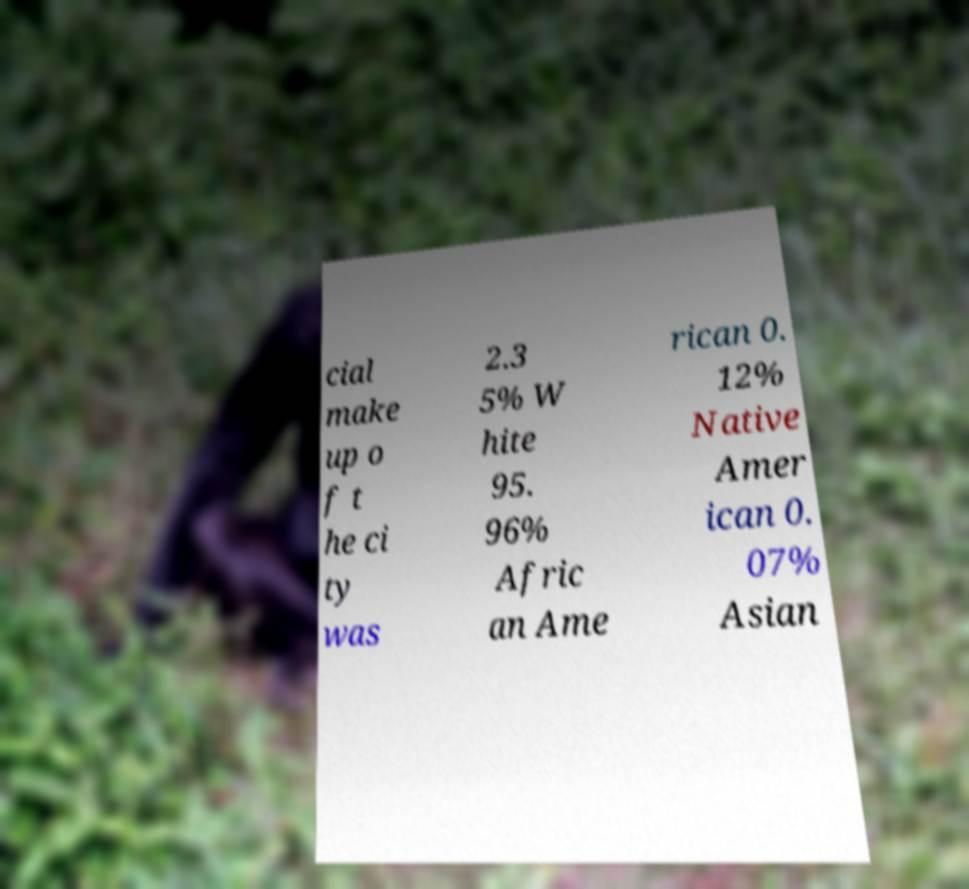Could you assist in decoding the text presented in this image and type it out clearly? cial make up o f t he ci ty was 2.3 5% W hite 95. 96% Afric an Ame rican 0. 12% Native Amer ican 0. 07% Asian 